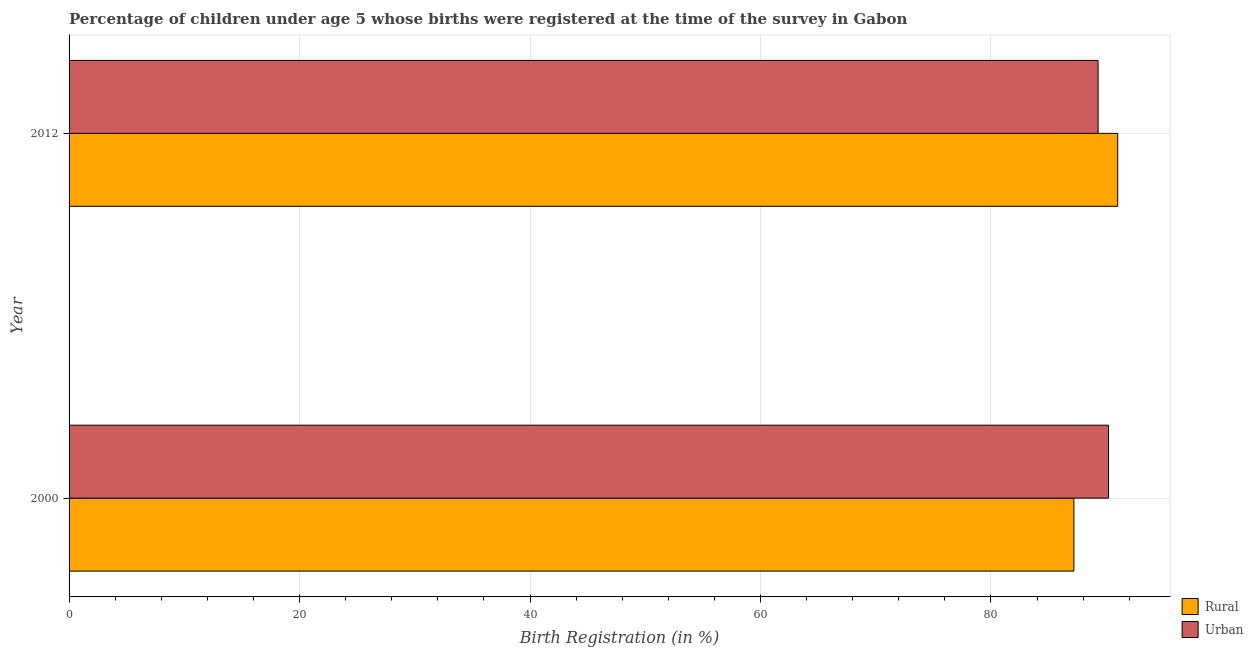Are the number of bars per tick equal to the number of legend labels?
Provide a succinct answer. Yes. Are the number of bars on each tick of the Y-axis equal?
Ensure brevity in your answer.  Yes. In how many cases, is the number of bars for a given year not equal to the number of legend labels?
Provide a short and direct response. 0. What is the rural birth registration in 2012?
Ensure brevity in your answer.  91. Across all years, what is the maximum urban birth registration?
Ensure brevity in your answer.  90.2. Across all years, what is the minimum rural birth registration?
Offer a very short reply. 87.2. In which year was the rural birth registration minimum?
Your answer should be very brief. 2000. What is the total urban birth registration in the graph?
Give a very brief answer. 179.5. What is the difference between the rural birth registration in 2000 and that in 2012?
Your answer should be very brief. -3.8. What is the difference between the urban birth registration in 2000 and the rural birth registration in 2012?
Provide a short and direct response. -0.8. What is the average urban birth registration per year?
Ensure brevity in your answer.  89.75. What is the ratio of the urban birth registration in 2000 to that in 2012?
Your answer should be compact. 1.01. Is the rural birth registration in 2000 less than that in 2012?
Provide a succinct answer. Yes. Is the difference between the urban birth registration in 2000 and 2012 greater than the difference between the rural birth registration in 2000 and 2012?
Your answer should be very brief. Yes. What does the 1st bar from the top in 2012 represents?
Your answer should be compact. Urban. What does the 2nd bar from the bottom in 2012 represents?
Give a very brief answer. Urban. How many bars are there?
Your answer should be very brief. 4. How many legend labels are there?
Ensure brevity in your answer.  2. What is the title of the graph?
Make the answer very short. Percentage of children under age 5 whose births were registered at the time of the survey in Gabon. Does "Urban" appear as one of the legend labels in the graph?
Provide a short and direct response. Yes. What is the label or title of the X-axis?
Keep it short and to the point. Birth Registration (in %). What is the Birth Registration (in %) in Rural in 2000?
Your answer should be compact. 87.2. What is the Birth Registration (in %) of Urban in 2000?
Give a very brief answer. 90.2. What is the Birth Registration (in %) in Rural in 2012?
Offer a terse response. 91. What is the Birth Registration (in %) of Urban in 2012?
Offer a terse response. 89.3. Across all years, what is the maximum Birth Registration (in %) in Rural?
Your answer should be very brief. 91. Across all years, what is the maximum Birth Registration (in %) in Urban?
Offer a very short reply. 90.2. Across all years, what is the minimum Birth Registration (in %) of Rural?
Offer a terse response. 87.2. Across all years, what is the minimum Birth Registration (in %) of Urban?
Provide a short and direct response. 89.3. What is the total Birth Registration (in %) in Rural in the graph?
Give a very brief answer. 178.2. What is the total Birth Registration (in %) in Urban in the graph?
Your answer should be very brief. 179.5. What is the difference between the Birth Registration (in %) in Rural in 2000 and the Birth Registration (in %) in Urban in 2012?
Make the answer very short. -2.1. What is the average Birth Registration (in %) in Rural per year?
Provide a succinct answer. 89.1. What is the average Birth Registration (in %) in Urban per year?
Keep it short and to the point. 89.75. In the year 2012, what is the difference between the Birth Registration (in %) of Rural and Birth Registration (in %) of Urban?
Give a very brief answer. 1.7. What is the ratio of the Birth Registration (in %) in Rural in 2000 to that in 2012?
Ensure brevity in your answer.  0.96. What is the difference between the highest and the second highest Birth Registration (in %) in Rural?
Ensure brevity in your answer.  3.8. What is the difference between the highest and the lowest Birth Registration (in %) in Urban?
Provide a short and direct response. 0.9. 